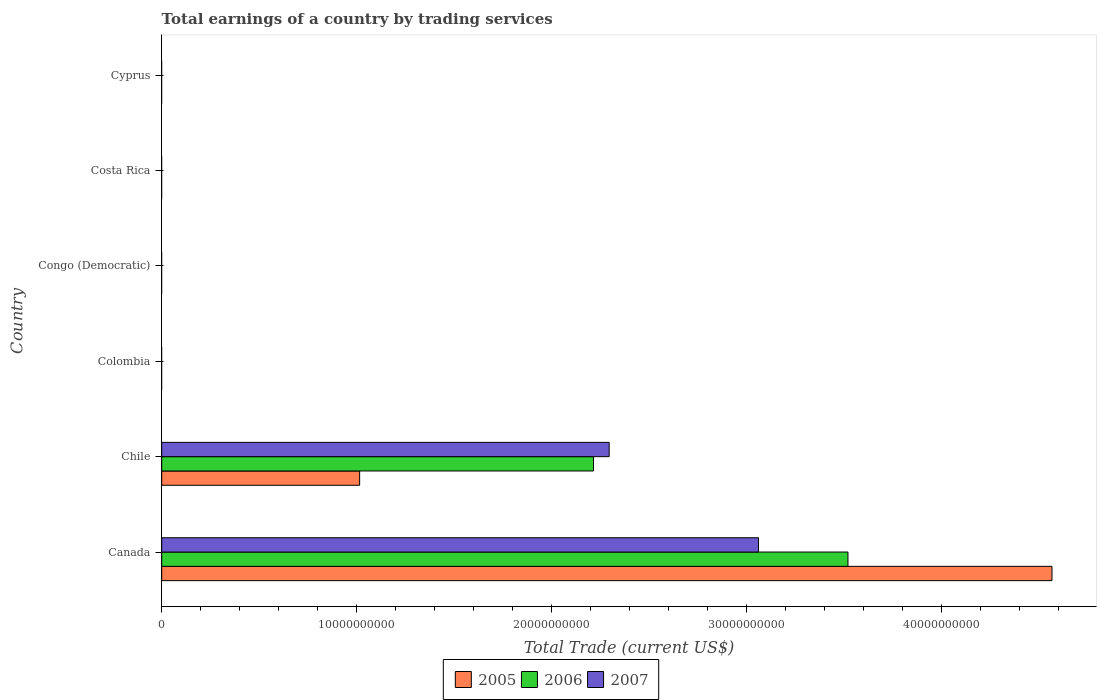Are the number of bars per tick equal to the number of legend labels?
Ensure brevity in your answer.  No. Are the number of bars on each tick of the Y-axis equal?
Your answer should be very brief. No. How many bars are there on the 4th tick from the top?
Provide a succinct answer. 0. What is the label of the 4th group of bars from the top?
Offer a very short reply. Colombia. In how many cases, is the number of bars for a given country not equal to the number of legend labels?
Your answer should be compact. 4. Across all countries, what is the maximum total earnings in 2006?
Give a very brief answer. 3.52e+1. What is the total total earnings in 2007 in the graph?
Keep it short and to the point. 5.36e+1. What is the difference between the total earnings in 2007 in Canada and that in Chile?
Offer a terse response. 7.66e+09. What is the difference between the total earnings in 2005 in Canada and the total earnings in 2006 in Colombia?
Your response must be concise. 4.57e+1. What is the average total earnings in 2006 per country?
Provide a short and direct response. 9.56e+09. What is the difference between the total earnings in 2006 and total earnings in 2005 in Canada?
Offer a very short reply. -1.05e+1. In how many countries, is the total earnings in 2005 greater than 44000000000 US$?
Keep it short and to the point. 1. What is the difference between the highest and the lowest total earnings in 2005?
Give a very brief answer. 4.57e+1. How many legend labels are there?
Ensure brevity in your answer.  3. How are the legend labels stacked?
Keep it short and to the point. Horizontal. What is the title of the graph?
Give a very brief answer. Total earnings of a country by trading services. Does "1970" appear as one of the legend labels in the graph?
Keep it short and to the point. No. What is the label or title of the X-axis?
Offer a terse response. Total Trade (current US$). What is the label or title of the Y-axis?
Provide a short and direct response. Country. What is the Total Trade (current US$) in 2005 in Canada?
Ensure brevity in your answer.  4.57e+1. What is the Total Trade (current US$) of 2006 in Canada?
Offer a very short reply. 3.52e+1. What is the Total Trade (current US$) in 2007 in Canada?
Make the answer very short. 3.06e+1. What is the Total Trade (current US$) in 2005 in Chile?
Offer a very short reply. 1.02e+1. What is the Total Trade (current US$) in 2006 in Chile?
Provide a short and direct response. 2.21e+1. What is the Total Trade (current US$) in 2007 in Chile?
Provide a succinct answer. 2.30e+1. What is the Total Trade (current US$) of 2007 in Colombia?
Offer a terse response. 0. What is the Total Trade (current US$) of 2006 in Costa Rica?
Provide a short and direct response. 0. What is the Total Trade (current US$) in 2007 in Costa Rica?
Make the answer very short. 0. What is the Total Trade (current US$) in 2005 in Cyprus?
Give a very brief answer. 0. What is the Total Trade (current US$) of 2006 in Cyprus?
Make the answer very short. 0. What is the Total Trade (current US$) of 2007 in Cyprus?
Provide a succinct answer. 0. Across all countries, what is the maximum Total Trade (current US$) in 2005?
Your response must be concise. 4.57e+1. Across all countries, what is the maximum Total Trade (current US$) in 2006?
Your answer should be compact. 3.52e+1. Across all countries, what is the maximum Total Trade (current US$) of 2007?
Offer a very short reply. 3.06e+1. What is the total Total Trade (current US$) in 2005 in the graph?
Your answer should be compact. 5.58e+1. What is the total Total Trade (current US$) of 2006 in the graph?
Ensure brevity in your answer.  5.74e+1. What is the total Total Trade (current US$) in 2007 in the graph?
Make the answer very short. 5.36e+1. What is the difference between the Total Trade (current US$) of 2005 in Canada and that in Chile?
Keep it short and to the point. 3.55e+1. What is the difference between the Total Trade (current US$) of 2006 in Canada and that in Chile?
Your answer should be very brief. 1.31e+1. What is the difference between the Total Trade (current US$) of 2007 in Canada and that in Chile?
Make the answer very short. 7.66e+09. What is the difference between the Total Trade (current US$) in 2005 in Canada and the Total Trade (current US$) in 2006 in Chile?
Make the answer very short. 2.35e+1. What is the difference between the Total Trade (current US$) in 2005 in Canada and the Total Trade (current US$) in 2007 in Chile?
Keep it short and to the point. 2.27e+1. What is the difference between the Total Trade (current US$) in 2006 in Canada and the Total Trade (current US$) in 2007 in Chile?
Provide a short and direct response. 1.22e+1. What is the average Total Trade (current US$) of 2005 per country?
Keep it short and to the point. 9.30e+09. What is the average Total Trade (current US$) of 2006 per country?
Make the answer very short. 9.56e+09. What is the average Total Trade (current US$) in 2007 per country?
Your answer should be compact. 8.93e+09. What is the difference between the Total Trade (current US$) in 2005 and Total Trade (current US$) in 2006 in Canada?
Offer a terse response. 1.05e+1. What is the difference between the Total Trade (current US$) of 2005 and Total Trade (current US$) of 2007 in Canada?
Offer a terse response. 1.51e+1. What is the difference between the Total Trade (current US$) in 2006 and Total Trade (current US$) in 2007 in Canada?
Ensure brevity in your answer.  4.59e+09. What is the difference between the Total Trade (current US$) in 2005 and Total Trade (current US$) in 2006 in Chile?
Provide a succinct answer. -1.20e+1. What is the difference between the Total Trade (current US$) of 2005 and Total Trade (current US$) of 2007 in Chile?
Provide a succinct answer. -1.28e+1. What is the difference between the Total Trade (current US$) of 2006 and Total Trade (current US$) of 2007 in Chile?
Ensure brevity in your answer.  -8.05e+08. What is the ratio of the Total Trade (current US$) of 2005 in Canada to that in Chile?
Offer a terse response. 4.5. What is the ratio of the Total Trade (current US$) of 2006 in Canada to that in Chile?
Offer a terse response. 1.59. What is the ratio of the Total Trade (current US$) in 2007 in Canada to that in Chile?
Give a very brief answer. 1.33. What is the difference between the highest and the lowest Total Trade (current US$) of 2005?
Your answer should be compact. 4.57e+1. What is the difference between the highest and the lowest Total Trade (current US$) in 2006?
Provide a succinct answer. 3.52e+1. What is the difference between the highest and the lowest Total Trade (current US$) in 2007?
Keep it short and to the point. 3.06e+1. 